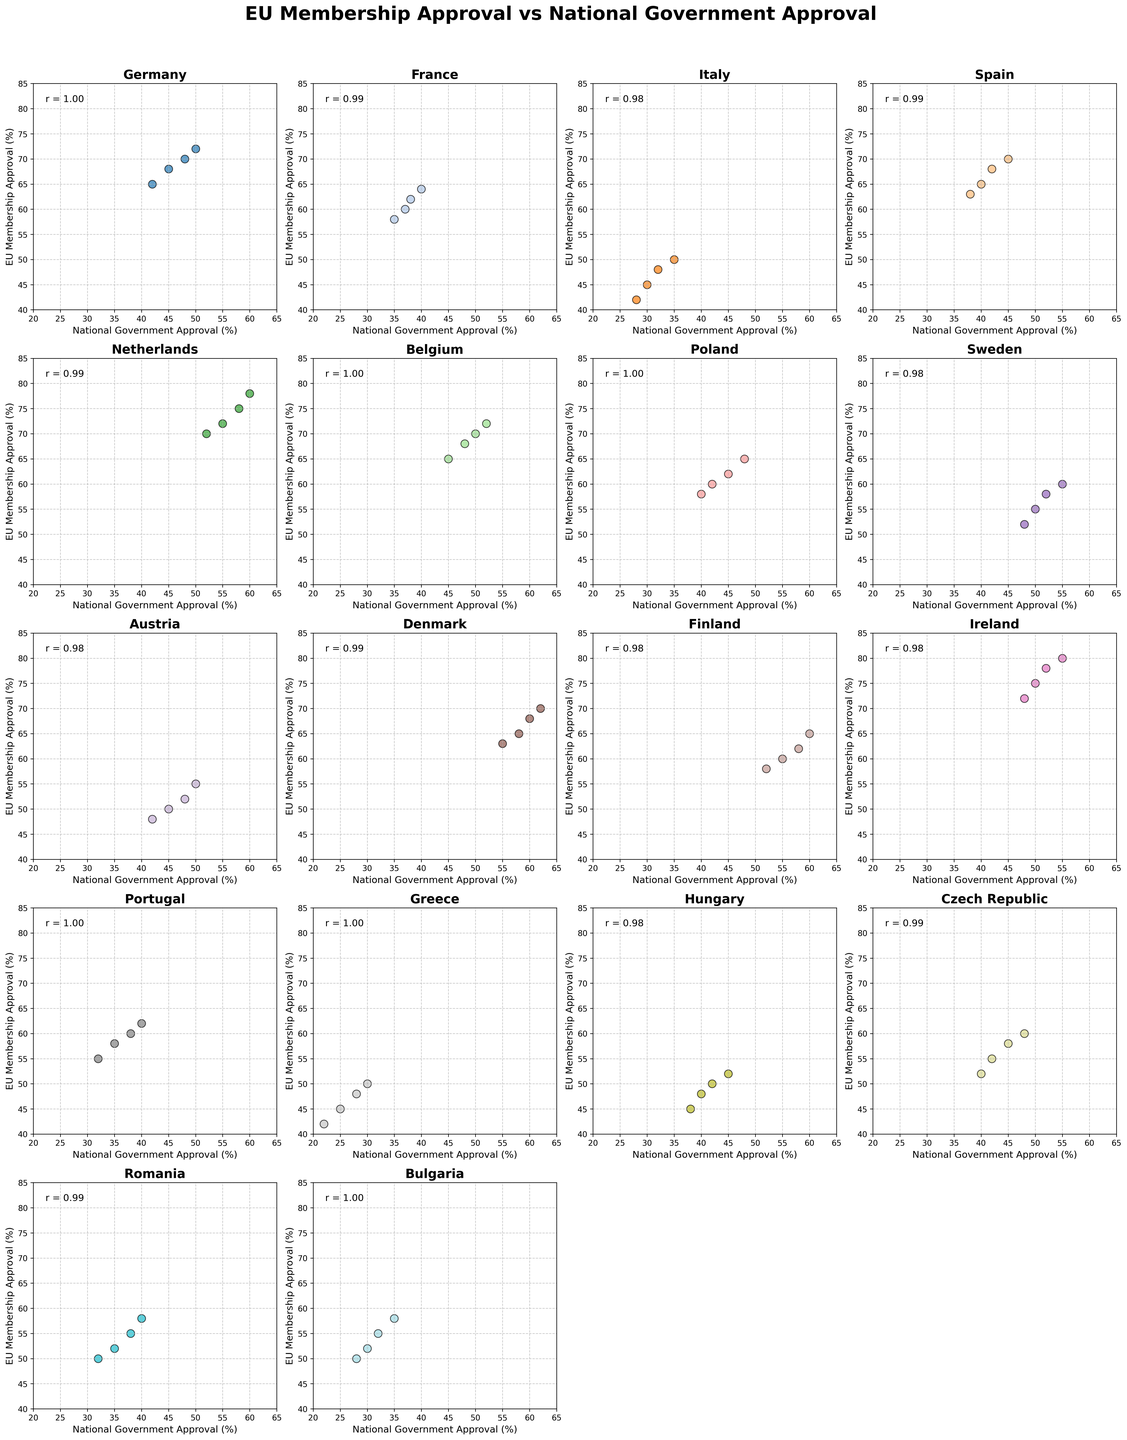Is there a positive correlation between EU Membership Approval and National Government Approval in Germany? To determine this, we need to look at the country-specific subplot for Germany. A correlation coefficient value (denoted as "r") near to 1 would indicate a strong positive correlation. The subplot indicates the correlation coefficient in the top-left area.
Answer: Yes Which country shows the highest overall EU Membership Approval rate? To find this, examine the highest y-values in each subplot of different countries and compare them. Netherlands and Ireland have some of the highest points around 80%.
Answer: Ireland In which country is the lowest National Government Approval observed? Identify the x-axis value for the minimum point across all country's subplots. Greece has the lowest point of 22%.
Answer: Greece Among the countries, which one exhibits the smallest spread between the highest and lowest points in EU Membership Approval? Check each subplot's y-axis to find the range (difference between highest and lowest points) within each country. Germany has a narrow range from 65 to 72.
Answer: Germany Are there any countries where EU Membership Approval does not strongly correlate with National Government Approval? Look for subplots where the correlation coefficient is closer to 0 or negative. France has a relatively weak correlation (r ≈ 0.88 compared to other higher values).
Answer: France Which country shows the largest deviation between the highest and lowest National Government Approval? Examine each subplot's x-axis to determine the largest range. Denmark ranges from 55 to 62, but Greece ranges from 22 to 30, which is wider.
Answer: Greece Is there any country where a high National Government Approval is consistently linked with low EU Membership Approval? Look for subplots where points with higher x-values (National Government Approval) are consistently associated with lower y-values (EU Membership Approval). No country shows this trend clearly.
Answer: No Which countries have a National Government Approval rate exceeding 50%? Identify the x-axis values greater than 50% across all subplots. Netherlands, Sweden, Denmark, Finland, Ireland.
Answer: Netherlands, Sweden, Denmark, Finland, Ireland Comparing Italy and Romania, which country has a higher median EU Membership Approval rate? Determine the median by ordering the y-axis values for both countries and then comparing the middle values. Italy has values 42, 45, 48, 50; median is 46.5. Romania has values 50, 52, 55, 58; median is 53.5. Hence, Romania’s is higher.
Answer: Romania Considering both Austria and Portugal, which has the greater average National Government Approval rate? Calculate the average x-axis value for National Government Approval in both subplots. Austria has 42, 45, 48, 50; average is (42+45+48+50)/4 = 46.25. Portugal has 32, 35, 38, 40; average is (32+35+38+40)/4 = 36.25. Austria has the greater average.
Answer: Austria 